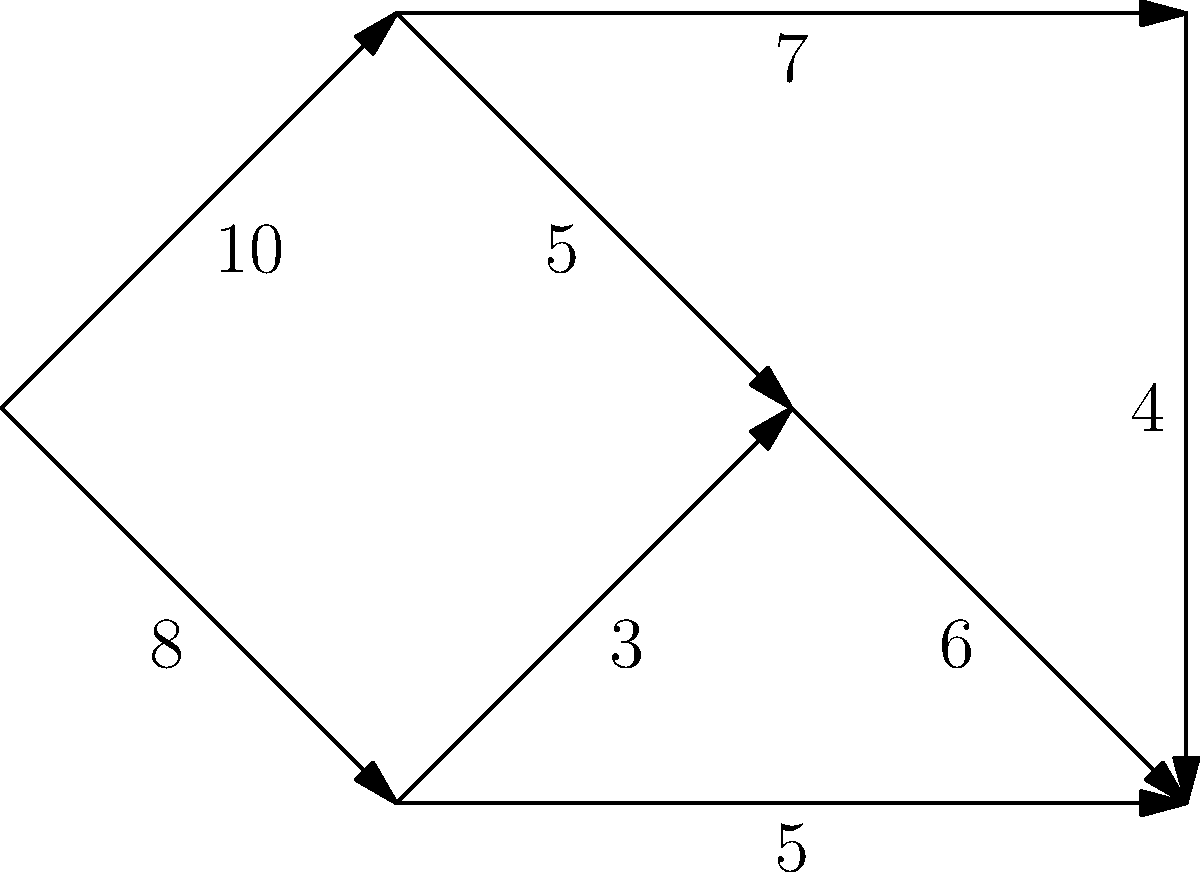You have designed an irrigation system for your organic farm, represented by the flow network above. The numbers on the edges represent the maximum water flow capacity (in gallons per minute) through each pipe. What is the maximum amount of water that can flow from the source (node 0) to the sink (node 5) per minute, and which paths should be used to achieve this maximum flow while minimizing water usage? To solve this problem, we'll use the Ford-Fulkerson algorithm to find the maximum flow in the network:

1. Initialize flow to 0 for all edges.

2. Find augmenting paths from source to sink:
   a) Path 1: 0 -> 1 -> 4 -> 5 (min capacity: 4)
      Update flow: 4 gallons/minute
   b) Path 2: 0 -> 3 -> 5 (min capacity: 5)
      Update flow: 4 + 5 = 9 gallons/minute
   c) Path 3: 0 -> 1 -> 2 -> 5 (min capacity: 5)
      Update flow: 9 + 5 = 14 gallons/minute
   d) Path 4: 0 -> 3 -> 2 -> 5 (min capacity: 1)
      Update flow: 14 + 1 = 15 gallons/minute

3. No more augmenting paths exist, so the maximum flow is 15 gallons/minute.

To minimize water usage while achieving maximum flow:
- Use path 0 -> 3 -> 5 for 5 gallons/minute
- Use path 0 -> 1 -> 2 -> 5 for 5 gallons/minute
- Use path 0 -> 1 -> 4 -> 5 for 4 gallons/minute
- Use path 0 -> 3 -> 2 -> 5 for 1 gallon/minute

This distribution ensures maximum flow while using the shortest possible paths, minimizing water loss due to evaporation or leakage.
Answer: Maximum flow: 15 gallons/minute. Paths: 0->3->5 (5), 0->1->2->5 (5), 0->1->4->5 (4), 0->3->2->5 (1). 